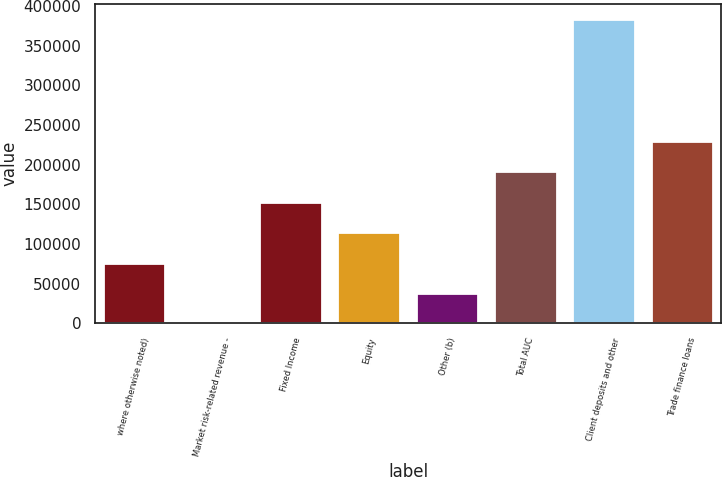Convert chart to OTSL. <chart><loc_0><loc_0><loc_500><loc_500><bar_chart><fcel>where otherwise noted)<fcel>Market risk-related revenue -<fcel>Fixed Income<fcel>Equity<fcel>Other (b)<fcel>Total AUC<fcel>Client deposits and other<fcel>Trade finance loans<nl><fcel>76736.9<fcel>4.39<fcel>153469<fcel>115103<fcel>38370.7<fcel>191836<fcel>383667<fcel>230202<nl></chart> 